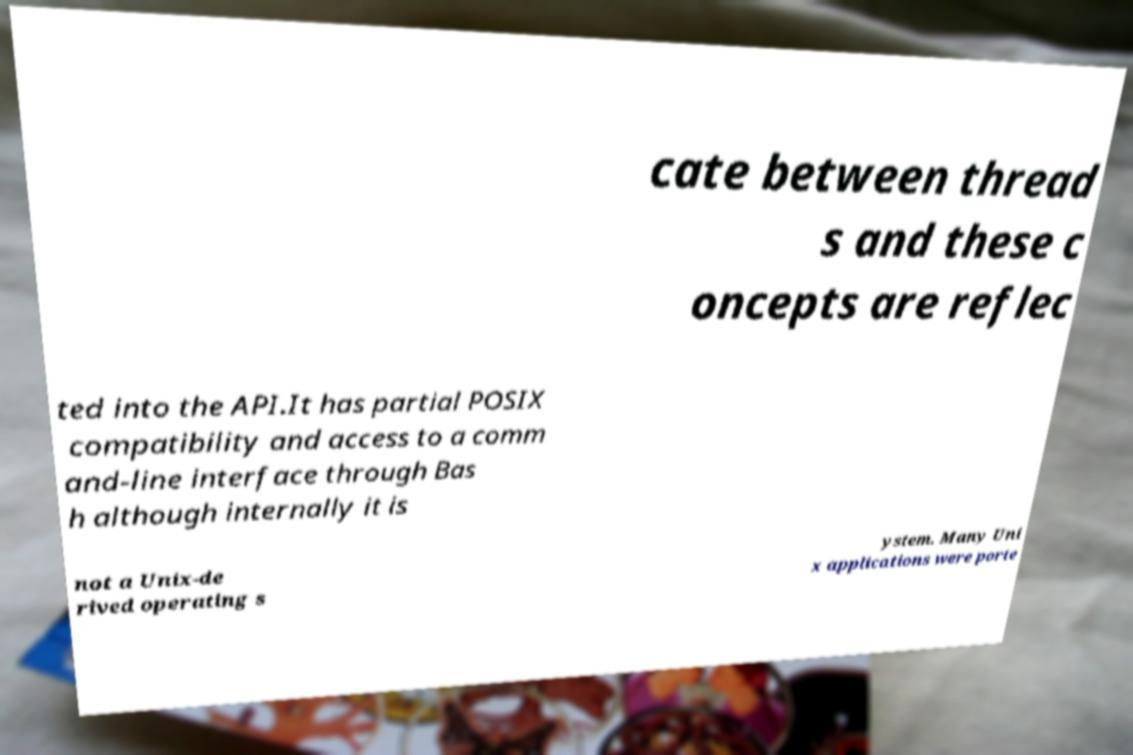Please read and relay the text visible in this image. What does it say? cate between thread s and these c oncepts are reflec ted into the API.It has partial POSIX compatibility and access to a comm and-line interface through Bas h although internally it is not a Unix-de rived operating s ystem. Many Uni x applications were porte 